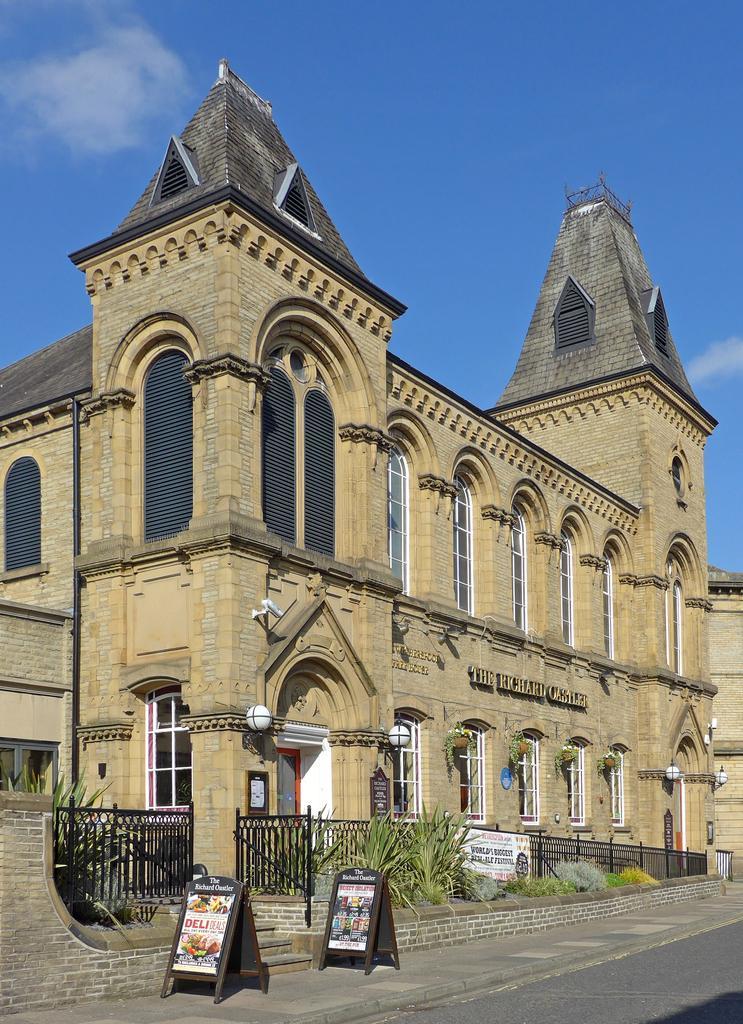Please provide a concise description of this image. In this image we can see sky with clouds, building, pipeline, cc camera, name board, grills, advertisement boards, plants and shrubs. 